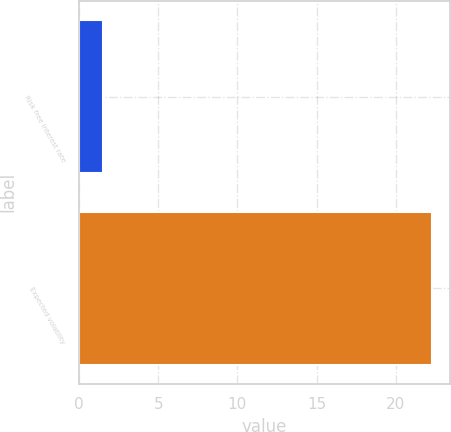Convert chart to OTSL. <chart><loc_0><loc_0><loc_500><loc_500><bar_chart><fcel>Risk free interest rate<fcel>Expected volatility<nl><fcel>1.52<fcel>22.3<nl></chart> 